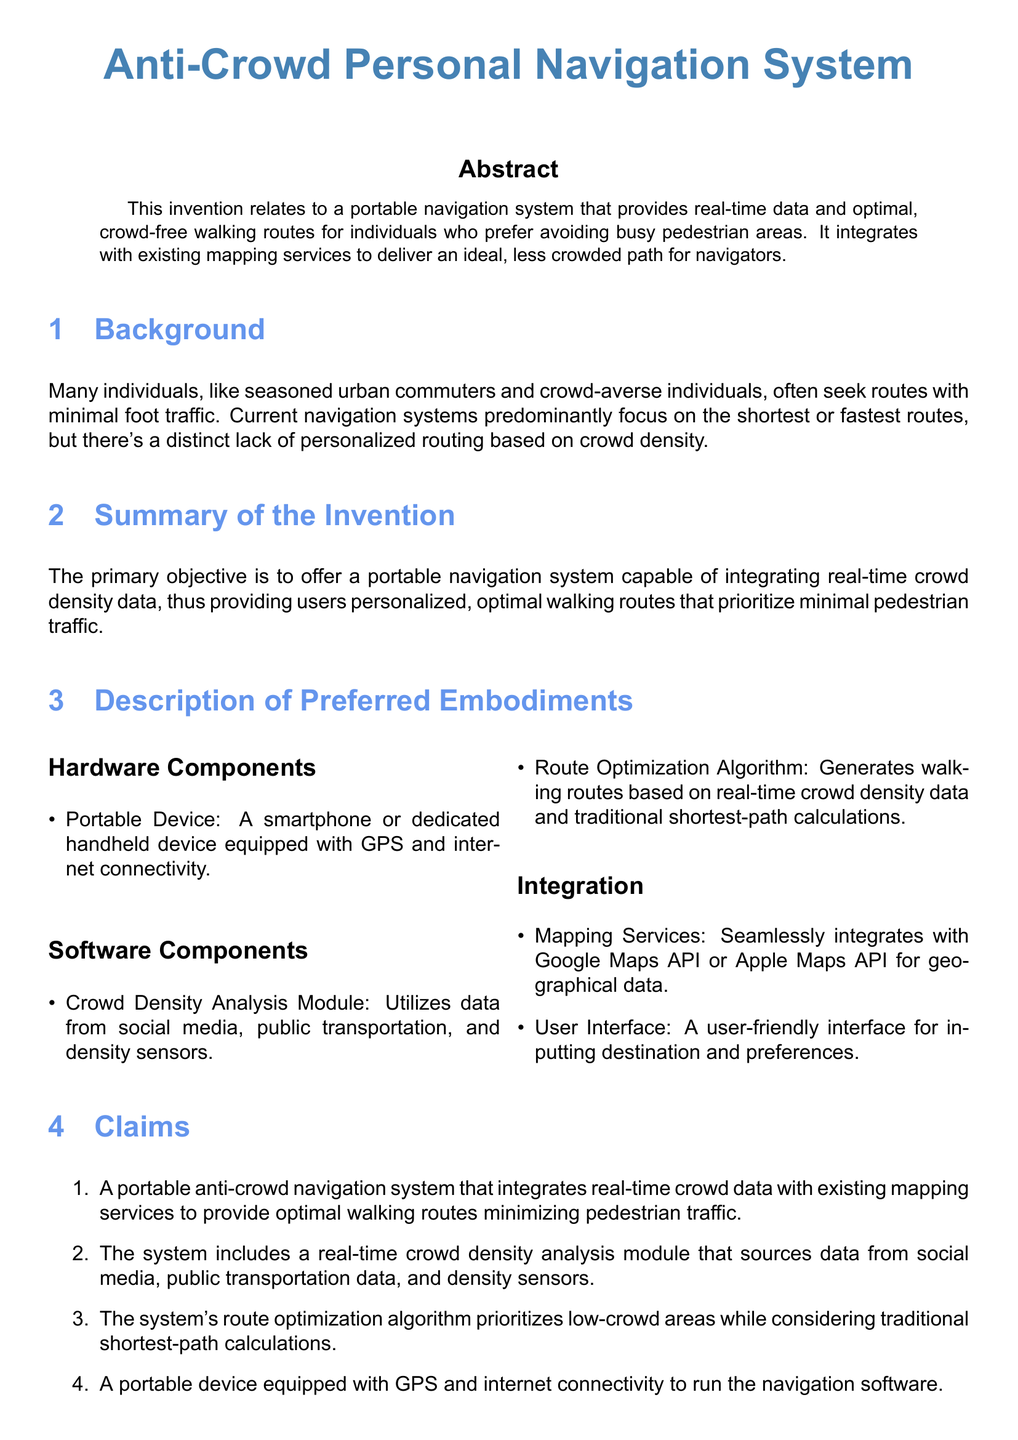What is the title of the invention? The title of the invention is stated at the beginning of the document.
Answer: Anti-Crowd Personal Navigation System What does the system integrate with? The document mentions that the navigational system integrates with existing mapping services.
Answer: Existing mapping services What is the primary objective of the invention? The objective is described in the summary of the invention section.
Answer: Provide personalized, optimal walking routes What data sources does the crowd density analysis module use? This information is listed in the description of preferred embodiments.
Answer: Social media, public transportation, density sensors Which algorithm does the system use for route optimization? The detailed description section provides this information.
Answer: Dijkstra's algorithm How does the system update real-time routes? The detailed description explains this process related to crowd density changes.
Answer: Using collected crowd data What type of device runs the navigation software? The details regarding the hardware component specify the type of device.
Answer: Portable device What are users required to input into the system? This detail is found in the integration section regarding user interaction.
Answer: Destination and preferences How many claims are stated in the document? The claims section lists the number of claims made.
Answer: Four claims 